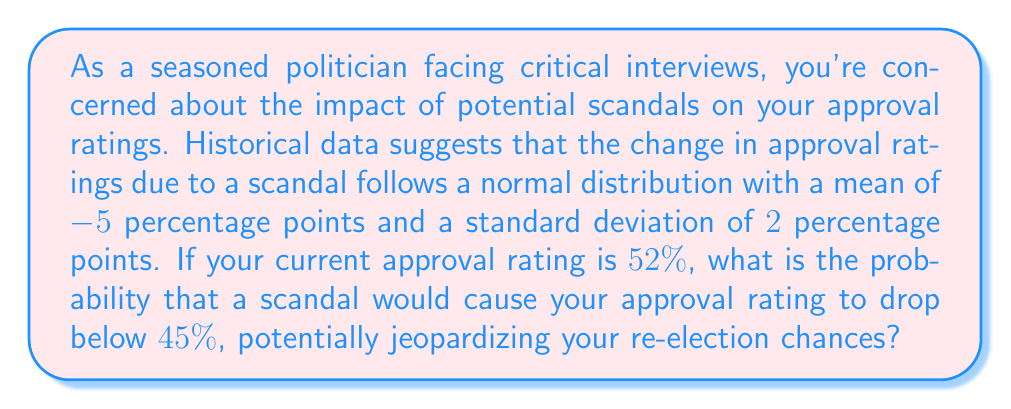Show me your answer to this math problem. To solve this problem, we need to use the properties of the normal distribution and calculate a z-score.

1. Identify the relevant information:
   - The change in approval ratings follows a normal distribution
   - Mean (μ) = -5 percentage points
   - Standard deviation (σ) = 2 percentage points
   - Current approval rating = 52%
   - Target approval rating = 45%

2. Calculate the required change in approval rating to reach the target:
   Change needed = 45% - 52% = -7 percentage points

3. Calculate the z-score for this change:
   $$z = \frac{x - \mu}{\sigma}$$
   where x is the change needed, μ is the mean, and σ is the standard deviation.

   $$z = \frac{-7 - (-5)}{2} = \frac{-2}{2} = -1$$

4. Use a standard normal distribution table or calculator to find the probability of a z-score less than or equal to -1.

5. The probability of a z-score less than or equal to -1 is approximately 0.1587 or 15.87%.

This means there is a 15.87% chance that a scandal would cause your approval rating to drop by 7 percentage points or more, bringing it below 45%.
Answer: The probability that a scandal would cause your approval rating to drop below 45% is approximately 0.1587 or 15.87%. 